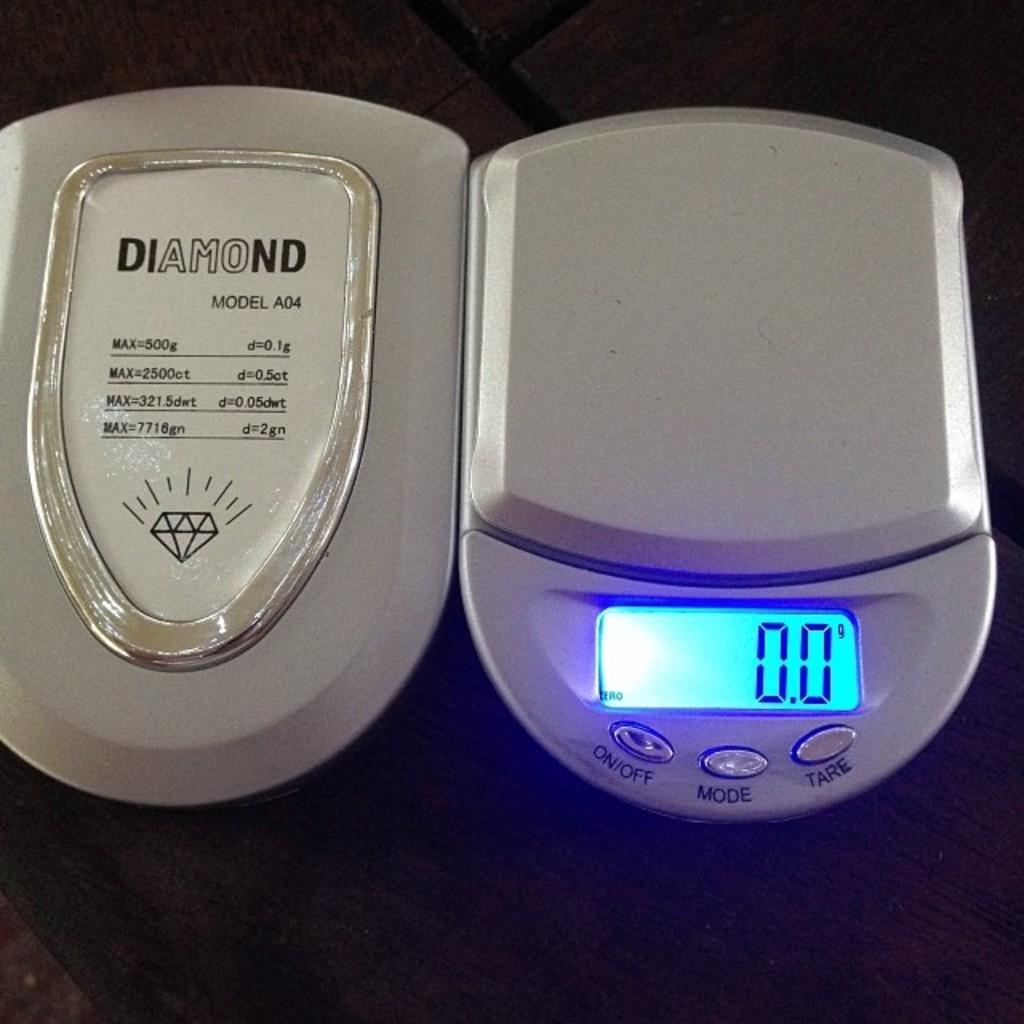<image>
Present a compact description of the photo's key features. A weight scale with 0.0 displayed with a silver Diamond model A04 next to it. 